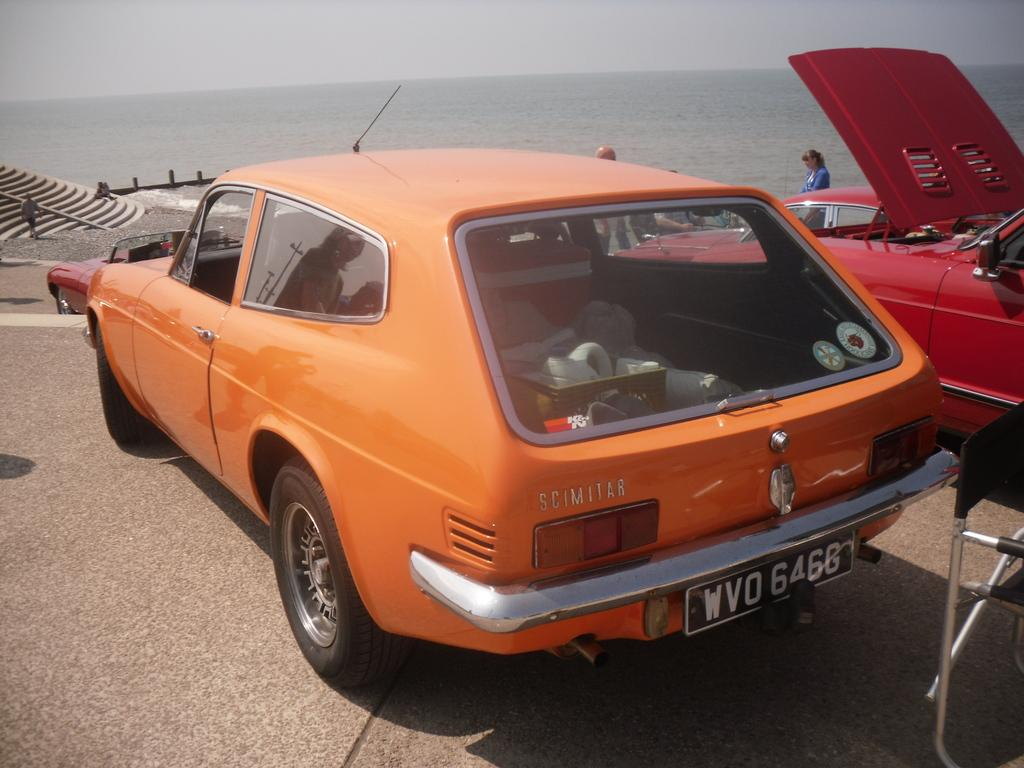What objects are on the floor in the image? There are motor vehicles on the floor in the image. What are the people in the image doing? There are persons standing in the image. What architectural feature can be seen in the image? There is a staircase in the image. What natural feature is visible in the image? The sea is visible in the image. What part of the sky is visible in the image? The sky is visible in the image. What type of punishment is being administered to the pail in the image? There is no pail present in the image, and therefore no punishment is being administered. 